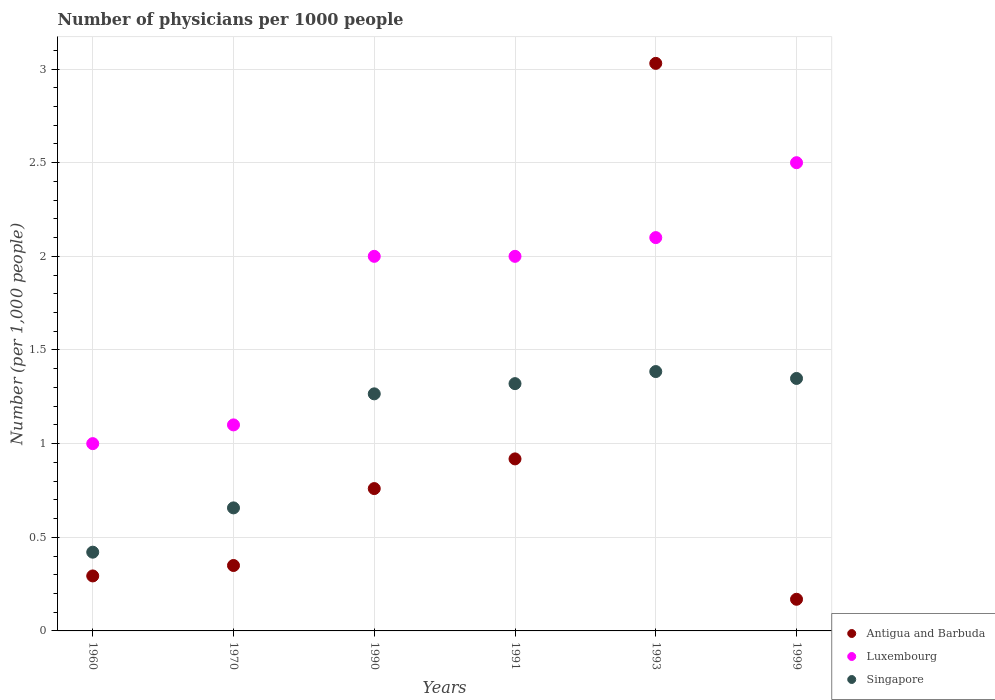Across all years, what is the maximum number of physicians in Luxembourg?
Your answer should be compact. 2.5. Across all years, what is the minimum number of physicians in Antigua and Barbuda?
Your answer should be compact. 0.17. What is the total number of physicians in Singapore in the graph?
Your answer should be very brief. 6.4. What is the difference between the number of physicians in Singapore in 1960 and that in 1990?
Give a very brief answer. -0.85. What is the difference between the number of physicians in Luxembourg in 1991 and the number of physicians in Antigua and Barbuda in 1999?
Make the answer very short. 1.83. What is the average number of physicians in Luxembourg per year?
Offer a terse response. 1.78. In the year 1993, what is the difference between the number of physicians in Antigua and Barbuda and number of physicians in Luxembourg?
Provide a succinct answer. 0.93. In how many years, is the number of physicians in Luxembourg greater than 1?
Offer a very short reply. 5. What is the ratio of the number of physicians in Luxembourg in 1960 to that in 1993?
Make the answer very short. 0.48. Is the number of physicians in Singapore in 1993 less than that in 1999?
Provide a short and direct response. No. Is the difference between the number of physicians in Antigua and Barbuda in 1960 and 1970 greater than the difference between the number of physicians in Luxembourg in 1960 and 1970?
Make the answer very short. Yes. What is the difference between the highest and the second highest number of physicians in Luxembourg?
Ensure brevity in your answer.  0.4. What is the difference between the highest and the lowest number of physicians in Luxembourg?
Your answer should be compact. 1.5. In how many years, is the number of physicians in Singapore greater than the average number of physicians in Singapore taken over all years?
Your answer should be very brief. 4. Is it the case that in every year, the sum of the number of physicians in Luxembourg and number of physicians in Antigua and Barbuda  is greater than the number of physicians in Singapore?
Offer a terse response. Yes. Does the number of physicians in Antigua and Barbuda monotonically increase over the years?
Provide a short and direct response. No. Is the number of physicians in Antigua and Barbuda strictly less than the number of physicians in Singapore over the years?
Your response must be concise. No. How many dotlines are there?
Offer a terse response. 3. How many years are there in the graph?
Your response must be concise. 6. What is the difference between two consecutive major ticks on the Y-axis?
Offer a very short reply. 0.5. Does the graph contain any zero values?
Ensure brevity in your answer.  No. How are the legend labels stacked?
Give a very brief answer. Vertical. What is the title of the graph?
Provide a short and direct response. Number of physicians per 1000 people. What is the label or title of the Y-axis?
Offer a terse response. Number (per 1,0 people). What is the Number (per 1,000 people) of Antigua and Barbuda in 1960?
Keep it short and to the point. 0.29. What is the Number (per 1,000 people) in Luxembourg in 1960?
Provide a succinct answer. 1. What is the Number (per 1,000 people) in Singapore in 1960?
Give a very brief answer. 0.42. What is the Number (per 1,000 people) in Antigua and Barbuda in 1970?
Make the answer very short. 0.35. What is the Number (per 1,000 people) in Luxembourg in 1970?
Offer a terse response. 1.1. What is the Number (per 1,000 people) in Singapore in 1970?
Ensure brevity in your answer.  0.66. What is the Number (per 1,000 people) in Antigua and Barbuda in 1990?
Provide a short and direct response. 0.76. What is the Number (per 1,000 people) in Luxembourg in 1990?
Give a very brief answer. 2. What is the Number (per 1,000 people) in Singapore in 1990?
Keep it short and to the point. 1.27. What is the Number (per 1,000 people) in Antigua and Barbuda in 1991?
Make the answer very short. 0.92. What is the Number (per 1,000 people) of Singapore in 1991?
Keep it short and to the point. 1.32. What is the Number (per 1,000 people) in Antigua and Barbuda in 1993?
Your response must be concise. 3.03. What is the Number (per 1,000 people) in Luxembourg in 1993?
Give a very brief answer. 2.1. What is the Number (per 1,000 people) of Singapore in 1993?
Provide a succinct answer. 1.38. What is the Number (per 1,000 people) in Antigua and Barbuda in 1999?
Your answer should be compact. 0.17. What is the Number (per 1,000 people) of Singapore in 1999?
Offer a very short reply. 1.35. Across all years, what is the maximum Number (per 1,000 people) in Antigua and Barbuda?
Your answer should be compact. 3.03. Across all years, what is the maximum Number (per 1,000 people) in Luxembourg?
Your answer should be compact. 2.5. Across all years, what is the maximum Number (per 1,000 people) of Singapore?
Provide a short and direct response. 1.38. Across all years, what is the minimum Number (per 1,000 people) of Antigua and Barbuda?
Your response must be concise. 0.17. Across all years, what is the minimum Number (per 1,000 people) in Singapore?
Your response must be concise. 0.42. What is the total Number (per 1,000 people) of Antigua and Barbuda in the graph?
Your response must be concise. 5.52. What is the total Number (per 1,000 people) in Singapore in the graph?
Offer a terse response. 6.4. What is the difference between the Number (per 1,000 people) in Antigua and Barbuda in 1960 and that in 1970?
Offer a very short reply. -0.06. What is the difference between the Number (per 1,000 people) in Singapore in 1960 and that in 1970?
Your answer should be very brief. -0.24. What is the difference between the Number (per 1,000 people) of Antigua and Barbuda in 1960 and that in 1990?
Provide a succinct answer. -0.47. What is the difference between the Number (per 1,000 people) in Luxembourg in 1960 and that in 1990?
Make the answer very short. -1. What is the difference between the Number (per 1,000 people) of Singapore in 1960 and that in 1990?
Keep it short and to the point. -0.85. What is the difference between the Number (per 1,000 people) in Antigua and Barbuda in 1960 and that in 1991?
Make the answer very short. -0.62. What is the difference between the Number (per 1,000 people) of Luxembourg in 1960 and that in 1991?
Your response must be concise. -1. What is the difference between the Number (per 1,000 people) of Singapore in 1960 and that in 1991?
Provide a short and direct response. -0.9. What is the difference between the Number (per 1,000 people) in Antigua and Barbuda in 1960 and that in 1993?
Your answer should be very brief. -2.74. What is the difference between the Number (per 1,000 people) of Luxembourg in 1960 and that in 1993?
Offer a very short reply. -1.1. What is the difference between the Number (per 1,000 people) of Singapore in 1960 and that in 1993?
Keep it short and to the point. -0.96. What is the difference between the Number (per 1,000 people) in Antigua and Barbuda in 1960 and that in 1999?
Ensure brevity in your answer.  0.12. What is the difference between the Number (per 1,000 people) of Singapore in 1960 and that in 1999?
Provide a short and direct response. -0.93. What is the difference between the Number (per 1,000 people) in Antigua and Barbuda in 1970 and that in 1990?
Keep it short and to the point. -0.41. What is the difference between the Number (per 1,000 people) in Singapore in 1970 and that in 1990?
Provide a short and direct response. -0.61. What is the difference between the Number (per 1,000 people) in Antigua and Barbuda in 1970 and that in 1991?
Your answer should be compact. -0.57. What is the difference between the Number (per 1,000 people) in Singapore in 1970 and that in 1991?
Keep it short and to the point. -0.66. What is the difference between the Number (per 1,000 people) of Antigua and Barbuda in 1970 and that in 1993?
Ensure brevity in your answer.  -2.68. What is the difference between the Number (per 1,000 people) of Luxembourg in 1970 and that in 1993?
Your response must be concise. -1. What is the difference between the Number (per 1,000 people) in Singapore in 1970 and that in 1993?
Provide a succinct answer. -0.73. What is the difference between the Number (per 1,000 people) in Antigua and Barbuda in 1970 and that in 1999?
Provide a short and direct response. 0.18. What is the difference between the Number (per 1,000 people) of Luxembourg in 1970 and that in 1999?
Keep it short and to the point. -1.4. What is the difference between the Number (per 1,000 people) in Singapore in 1970 and that in 1999?
Offer a very short reply. -0.69. What is the difference between the Number (per 1,000 people) of Antigua and Barbuda in 1990 and that in 1991?
Your answer should be compact. -0.16. What is the difference between the Number (per 1,000 people) in Luxembourg in 1990 and that in 1991?
Offer a terse response. 0. What is the difference between the Number (per 1,000 people) of Singapore in 1990 and that in 1991?
Keep it short and to the point. -0.05. What is the difference between the Number (per 1,000 people) of Antigua and Barbuda in 1990 and that in 1993?
Keep it short and to the point. -2.27. What is the difference between the Number (per 1,000 people) of Singapore in 1990 and that in 1993?
Make the answer very short. -0.12. What is the difference between the Number (per 1,000 people) in Antigua and Barbuda in 1990 and that in 1999?
Keep it short and to the point. 0.59. What is the difference between the Number (per 1,000 people) of Luxembourg in 1990 and that in 1999?
Your answer should be very brief. -0.5. What is the difference between the Number (per 1,000 people) in Singapore in 1990 and that in 1999?
Offer a terse response. -0.08. What is the difference between the Number (per 1,000 people) of Antigua and Barbuda in 1991 and that in 1993?
Offer a terse response. -2.11. What is the difference between the Number (per 1,000 people) in Singapore in 1991 and that in 1993?
Keep it short and to the point. -0.06. What is the difference between the Number (per 1,000 people) of Antigua and Barbuda in 1991 and that in 1999?
Your answer should be very brief. 0.75. What is the difference between the Number (per 1,000 people) of Singapore in 1991 and that in 1999?
Provide a succinct answer. -0.03. What is the difference between the Number (per 1,000 people) of Antigua and Barbuda in 1993 and that in 1999?
Your response must be concise. 2.86. What is the difference between the Number (per 1,000 people) of Singapore in 1993 and that in 1999?
Ensure brevity in your answer.  0.04. What is the difference between the Number (per 1,000 people) of Antigua and Barbuda in 1960 and the Number (per 1,000 people) of Luxembourg in 1970?
Give a very brief answer. -0.81. What is the difference between the Number (per 1,000 people) of Antigua and Barbuda in 1960 and the Number (per 1,000 people) of Singapore in 1970?
Keep it short and to the point. -0.36. What is the difference between the Number (per 1,000 people) of Luxembourg in 1960 and the Number (per 1,000 people) of Singapore in 1970?
Your answer should be compact. 0.34. What is the difference between the Number (per 1,000 people) in Antigua and Barbuda in 1960 and the Number (per 1,000 people) in Luxembourg in 1990?
Ensure brevity in your answer.  -1.71. What is the difference between the Number (per 1,000 people) of Antigua and Barbuda in 1960 and the Number (per 1,000 people) of Singapore in 1990?
Your answer should be very brief. -0.97. What is the difference between the Number (per 1,000 people) in Luxembourg in 1960 and the Number (per 1,000 people) in Singapore in 1990?
Give a very brief answer. -0.27. What is the difference between the Number (per 1,000 people) of Antigua and Barbuda in 1960 and the Number (per 1,000 people) of Luxembourg in 1991?
Ensure brevity in your answer.  -1.71. What is the difference between the Number (per 1,000 people) in Antigua and Barbuda in 1960 and the Number (per 1,000 people) in Singapore in 1991?
Your response must be concise. -1.03. What is the difference between the Number (per 1,000 people) of Luxembourg in 1960 and the Number (per 1,000 people) of Singapore in 1991?
Provide a short and direct response. -0.32. What is the difference between the Number (per 1,000 people) of Antigua and Barbuda in 1960 and the Number (per 1,000 people) of Luxembourg in 1993?
Your answer should be compact. -1.81. What is the difference between the Number (per 1,000 people) in Antigua and Barbuda in 1960 and the Number (per 1,000 people) in Singapore in 1993?
Give a very brief answer. -1.09. What is the difference between the Number (per 1,000 people) in Luxembourg in 1960 and the Number (per 1,000 people) in Singapore in 1993?
Make the answer very short. -0.38. What is the difference between the Number (per 1,000 people) of Antigua and Barbuda in 1960 and the Number (per 1,000 people) of Luxembourg in 1999?
Make the answer very short. -2.21. What is the difference between the Number (per 1,000 people) of Antigua and Barbuda in 1960 and the Number (per 1,000 people) of Singapore in 1999?
Provide a succinct answer. -1.05. What is the difference between the Number (per 1,000 people) of Luxembourg in 1960 and the Number (per 1,000 people) of Singapore in 1999?
Your response must be concise. -0.35. What is the difference between the Number (per 1,000 people) of Antigua and Barbuda in 1970 and the Number (per 1,000 people) of Luxembourg in 1990?
Your response must be concise. -1.65. What is the difference between the Number (per 1,000 people) of Antigua and Barbuda in 1970 and the Number (per 1,000 people) of Singapore in 1990?
Provide a succinct answer. -0.92. What is the difference between the Number (per 1,000 people) in Luxembourg in 1970 and the Number (per 1,000 people) in Singapore in 1990?
Offer a very short reply. -0.17. What is the difference between the Number (per 1,000 people) of Antigua and Barbuda in 1970 and the Number (per 1,000 people) of Luxembourg in 1991?
Provide a succinct answer. -1.65. What is the difference between the Number (per 1,000 people) in Antigua and Barbuda in 1970 and the Number (per 1,000 people) in Singapore in 1991?
Make the answer very short. -0.97. What is the difference between the Number (per 1,000 people) in Luxembourg in 1970 and the Number (per 1,000 people) in Singapore in 1991?
Make the answer very short. -0.22. What is the difference between the Number (per 1,000 people) in Antigua and Barbuda in 1970 and the Number (per 1,000 people) in Luxembourg in 1993?
Keep it short and to the point. -1.75. What is the difference between the Number (per 1,000 people) of Antigua and Barbuda in 1970 and the Number (per 1,000 people) of Singapore in 1993?
Your answer should be compact. -1.04. What is the difference between the Number (per 1,000 people) of Luxembourg in 1970 and the Number (per 1,000 people) of Singapore in 1993?
Offer a terse response. -0.28. What is the difference between the Number (per 1,000 people) of Antigua and Barbuda in 1970 and the Number (per 1,000 people) of Luxembourg in 1999?
Ensure brevity in your answer.  -2.15. What is the difference between the Number (per 1,000 people) of Antigua and Barbuda in 1970 and the Number (per 1,000 people) of Singapore in 1999?
Ensure brevity in your answer.  -1. What is the difference between the Number (per 1,000 people) of Luxembourg in 1970 and the Number (per 1,000 people) of Singapore in 1999?
Provide a succinct answer. -0.25. What is the difference between the Number (per 1,000 people) of Antigua and Barbuda in 1990 and the Number (per 1,000 people) of Luxembourg in 1991?
Provide a succinct answer. -1.24. What is the difference between the Number (per 1,000 people) in Antigua and Barbuda in 1990 and the Number (per 1,000 people) in Singapore in 1991?
Offer a very short reply. -0.56. What is the difference between the Number (per 1,000 people) of Luxembourg in 1990 and the Number (per 1,000 people) of Singapore in 1991?
Make the answer very short. 0.68. What is the difference between the Number (per 1,000 people) in Antigua and Barbuda in 1990 and the Number (per 1,000 people) in Luxembourg in 1993?
Give a very brief answer. -1.34. What is the difference between the Number (per 1,000 people) of Antigua and Barbuda in 1990 and the Number (per 1,000 people) of Singapore in 1993?
Provide a succinct answer. -0.62. What is the difference between the Number (per 1,000 people) in Luxembourg in 1990 and the Number (per 1,000 people) in Singapore in 1993?
Provide a succinct answer. 0.62. What is the difference between the Number (per 1,000 people) of Antigua and Barbuda in 1990 and the Number (per 1,000 people) of Luxembourg in 1999?
Provide a succinct answer. -1.74. What is the difference between the Number (per 1,000 people) in Antigua and Barbuda in 1990 and the Number (per 1,000 people) in Singapore in 1999?
Your answer should be very brief. -0.59. What is the difference between the Number (per 1,000 people) in Luxembourg in 1990 and the Number (per 1,000 people) in Singapore in 1999?
Give a very brief answer. 0.65. What is the difference between the Number (per 1,000 people) of Antigua and Barbuda in 1991 and the Number (per 1,000 people) of Luxembourg in 1993?
Your answer should be very brief. -1.18. What is the difference between the Number (per 1,000 people) of Antigua and Barbuda in 1991 and the Number (per 1,000 people) of Singapore in 1993?
Make the answer very short. -0.47. What is the difference between the Number (per 1,000 people) in Luxembourg in 1991 and the Number (per 1,000 people) in Singapore in 1993?
Offer a very short reply. 0.62. What is the difference between the Number (per 1,000 people) in Antigua and Barbuda in 1991 and the Number (per 1,000 people) in Luxembourg in 1999?
Your response must be concise. -1.58. What is the difference between the Number (per 1,000 people) in Antigua and Barbuda in 1991 and the Number (per 1,000 people) in Singapore in 1999?
Keep it short and to the point. -0.43. What is the difference between the Number (per 1,000 people) in Luxembourg in 1991 and the Number (per 1,000 people) in Singapore in 1999?
Keep it short and to the point. 0.65. What is the difference between the Number (per 1,000 people) in Antigua and Barbuda in 1993 and the Number (per 1,000 people) in Luxembourg in 1999?
Offer a terse response. 0.53. What is the difference between the Number (per 1,000 people) of Antigua and Barbuda in 1993 and the Number (per 1,000 people) of Singapore in 1999?
Offer a terse response. 1.68. What is the difference between the Number (per 1,000 people) of Luxembourg in 1993 and the Number (per 1,000 people) of Singapore in 1999?
Your response must be concise. 0.75. What is the average Number (per 1,000 people) in Antigua and Barbuda per year?
Offer a very short reply. 0.92. What is the average Number (per 1,000 people) of Luxembourg per year?
Give a very brief answer. 1.78. What is the average Number (per 1,000 people) of Singapore per year?
Offer a very short reply. 1.07. In the year 1960, what is the difference between the Number (per 1,000 people) of Antigua and Barbuda and Number (per 1,000 people) of Luxembourg?
Offer a very short reply. -0.71. In the year 1960, what is the difference between the Number (per 1,000 people) in Antigua and Barbuda and Number (per 1,000 people) in Singapore?
Your response must be concise. -0.13. In the year 1960, what is the difference between the Number (per 1,000 people) in Luxembourg and Number (per 1,000 people) in Singapore?
Your answer should be very brief. 0.58. In the year 1970, what is the difference between the Number (per 1,000 people) of Antigua and Barbuda and Number (per 1,000 people) of Luxembourg?
Give a very brief answer. -0.75. In the year 1970, what is the difference between the Number (per 1,000 people) in Antigua and Barbuda and Number (per 1,000 people) in Singapore?
Your answer should be compact. -0.31. In the year 1970, what is the difference between the Number (per 1,000 people) in Luxembourg and Number (per 1,000 people) in Singapore?
Your response must be concise. 0.44. In the year 1990, what is the difference between the Number (per 1,000 people) in Antigua and Barbuda and Number (per 1,000 people) in Luxembourg?
Give a very brief answer. -1.24. In the year 1990, what is the difference between the Number (per 1,000 people) in Antigua and Barbuda and Number (per 1,000 people) in Singapore?
Keep it short and to the point. -0.51. In the year 1990, what is the difference between the Number (per 1,000 people) of Luxembourg and Number (per 1,000 people) of Singapore?
Offer a very short reply. 0.73. In the year 1991, what is the difference between the Number (per 1,000 people) of Antigua and Barbuda and Number (per 1,000 people) of Luxembourg?
Your response must be concise. -1.08. In the year 1991, what is the difference between the Number (per 1,000 people) of Antigua and Barbuda and Number (per 1,000 people) of Singapore?
Your answer should be compact. -0.4. In the year 1991, what is the difference between the Number (per 1,000 people) in Luxembourg and Number (per 1,000 people) in Singapore?
Keep it short and to the point. 0.68. In the year 1993, what is the difference between the Number (per 1,000 people) of Antigua and Barbuda and Number (per 1,000 people) of Luxembourg?
Provide a succinct answer. 0.93. In the year 1993, what is the difference between the Number (per 1,000 people) in Antigua and Barbuda and Number (per 1,000 people) in Singapore?
Provide a succinct answer. 1.65. In the year 1993, what is the difference between the Number (per 1,000 people) in Luxembourg and Number (per 1,000 people) in Singapore?
Your answer should be very brief. 0.72. In the year 1999, what is the difference between the Number (per 1,000 people) in Antigua and Barbuda and Number (per 1,000 people) in Luxembourg?
Ensure brevity in your answer.  -2.33. In the year 1999, what is the difference between the Number (per 1,000 people) of Antigua and Barbuda and Number (per 1,000 people) of Singapore?
Offer a terse response. -1.18. In the year 1999, what is the difference between the Number (per 1,000 people) in Luxembourg and Number (per 1,000 people) in Singapore?
Your answer should be very brief. 1.15. What is the ratio of the Number (per 1,000 people) of Antigua and Barbuda in 1960 to that in 1970?
Offer a very short reply. 0.84. What is the ratio of the Number (per 1,000 people) in Singapore in 1960 to that in 1970?
Your answer should be compact. 0.64. What is the ratio of the Number (per 1,000 people) in Antigua and Barbuda in 1960 to that in 1990?
Your answer should be compact. 0.39. What is the ratio of the Number (per 1,000 people) of Luxembourg in 1960 to that in 1990?
Make the answer very short. 0.5. What is the ratio of the Number (per 1,000 people) in Singapore in 1960 to that in 1990?
Your response must be concise. 0.33. What is the ratio of the Number (per 1,000 people) of Antigua and Barbuda in 1960 to that in 1991?
Your answer should be compact. 0.32. What is the ratio of the Number (per 1,000 people) of Singapore in 1960 to that in 1991?
Your answer should be very brief. 0.32. What is the ratio of the Number (per 1,000 people) in Antigua and Barbuda in 1960 to that in 1993?
Your answer should be compact. 0.1. What is the ratio of the Number (per 1,000 people) of Luxembourg in 1960 to that in 1993?
Your answer should be compact. 0.48. What is the ratio of the Number (per 1,000 people) in Singapore in 1960 to that in 1993?
Your response must be concise. 0.3. What is the ratio of the Number (per 1,000 people) in Antigua and Barbuda in 1960 to that in 1999?
Keep it short and to the point. 1.74. What is the ratio of the Number (per 1,000 people) in Singapore in 1960 to that in 1999?
Provide a short and direct response. 0.31. What is the ratio of the Number (per 1,000 people) in Antigua and Barbuda in 1970 to that in 1990?
Ensure brevity in your answer.  0.46. What is the ratio of the Number (per 1,000 people) of Luxembourg in 1970 to that in 1990?
Your response must be concise. 0.55. What is the ratio of the Number (per 1,000 people) of Singapore in 1970 to that in 1990?
Offer a terse response. 0.52. What is the ratio of the Number (per 1,000 people) in Antigua and Barbuda in 1970 to that in 1991?
Provide a short and direct response. 0.38. What is the ratio of the Number (per 1,000 people) of Luxembourg in 1970 to that in 1991?
Offer a very short reply. 0.55. What is the ratio of the Number (per 1,000 people) of Singapore in 1970 to that in 1991?
Your answer should be compact. 0.5. What is the ratio of the Number (per 1,000 people) in Antigua and Barbuda in 1970 to that in 1993?
Keep it short and to the point. 0.12. What is the ratio of the Number (per 1,000 people) in Luxembourg in 1970 to that in 1993?
Your answer should be compact. 0.52. What is the ratio of the Number (per 1,000 people) in Singapore in 1970 to that in 1993?
Your answer should be compact. 0.47. What is the ratio of the Number (per 1,000 people) in Antigua and Barbuda in 1970 to that in 1999?
Your answer should be very brief. 2.07. What is the ratio of the Number (per 1,000 people) of Luxembourg in 1970 to that in 1999?
Give a very brief answer. 0.44. What is the ratio of the Number (per 1,000 people) of Singapore in 1970 to that in 1999?
Provide a short and direct response. 0.49. What is the ratio of the Number (per 1,000 people) of Antigua and Barbuda in 1990 to that in 1991?
Your response must be concise. 0.83. What is the ratio of the Number (per 1,000 people) of Singapore in 1990 to that in 1991?
Your answer should be very brief. 0.96. What is the ratio of the Number (per 1,000 people) of Antigua and Barbuda in 1990 to that in 1993?
Keep it short and to the point. 0.25. What is the ratio of the Number (per 1,000 people) in Singapore in 1990 to that in 1993?
Offer a very short reply. 0.91. What is the ratio of the Number (per 1,000 people) of Antigua and Barbuda in 1990 to that in 1999?
Your answer should be compact. 4.5. What is the ratio of the Number (per 1,000 people) of Luxembourg in 1990 to that in 1999?
Your answer should be very brief. 0.8. What is the ratio of the Number (per 1,000 people) in Singapore in 1990 to that in 1999?
Offer a very short reply. 0.94. What is the ratio of the Number (per 1,000 people) in Antigua and Barbuda in 1991 to that in 1993?
Provide a succinct answer. 0.3. What is the ratio of the Number (per 1,000 people) of Singapore in 1991 to that in 1993?
Keep it short and to the point. 0.95. What is the ratio of the Number (per 1,000 people) of Antigua and Barbuda in 1991 to that in 1999?
Keep it short and to the point. 5.43. What is the ratio of the Number (per 1,000 people) of Luxembourg in 1991 to that in 1999?
Provide a succinct answer. 0.8. What is the ratio of the Number (per 1,000 people) in Singapore in 1991 to that in 1999?
Offer a very short reply. 0.98. What is the ratio of the Number (per 1,000 people) in Antigua and Barbuda in 1993 to that in 1999?
Provide a short and direct response. 17.93. What is the ratio of the Number (per 1,000 people) in Luxembourg in 1993 to that in 1999?
Your response must be concise. 0.84. What is the ratio of the Number (per 1,000 people) in Singapore in 1993 to that in 1999?
Provide a succinct answer. 1.03. What is the difference between the highest and the second highest Number (per 1,000 people) in Antigua and Barbuda?
Your answer should be compact. 2.11. What is the difference between the highest and the second highest Number (per 1,000 people) of Singapore?
Provide a succinct answer. 0.04. What is the difference between the highest and the lowest Number (per 1,000 people) in Antigua and Barbuda?
Give a very brief answer. 2.86. What is the difference between the highest and the lowest Number (per 1,000 people) in Singapore?
Your answer should be very brief. 0.96. 